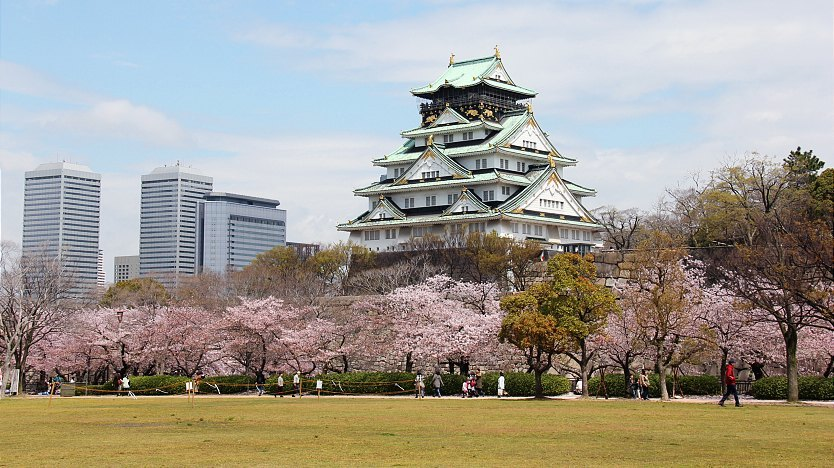Does Osaka Castle have any hidden or secret passages? Describe one in detail. While many ancient castles have legends of secret passages, Osaka Castle indeed has hidden chambers and escape routes used during times of siege. One renowned secret passage is said to lead from the main keep to a concealed exit beyond the castle walls. This passage, dimly lit and narrow, was designed for the stealthy escape of the castle lords during an attack. The stone walls are lined with ancient inscriptions and marks from past inhabitants. The air is cool and slightly damp, with a sense of history etched into every corner. As you navigate through this winding tunnel, the echo of your footsteps mirrors the clandestine travels of sharegpt4v/samurai and lords from centuries ago, offering a tangible connection to the past and the strategic ingenuity of the castle's design. 